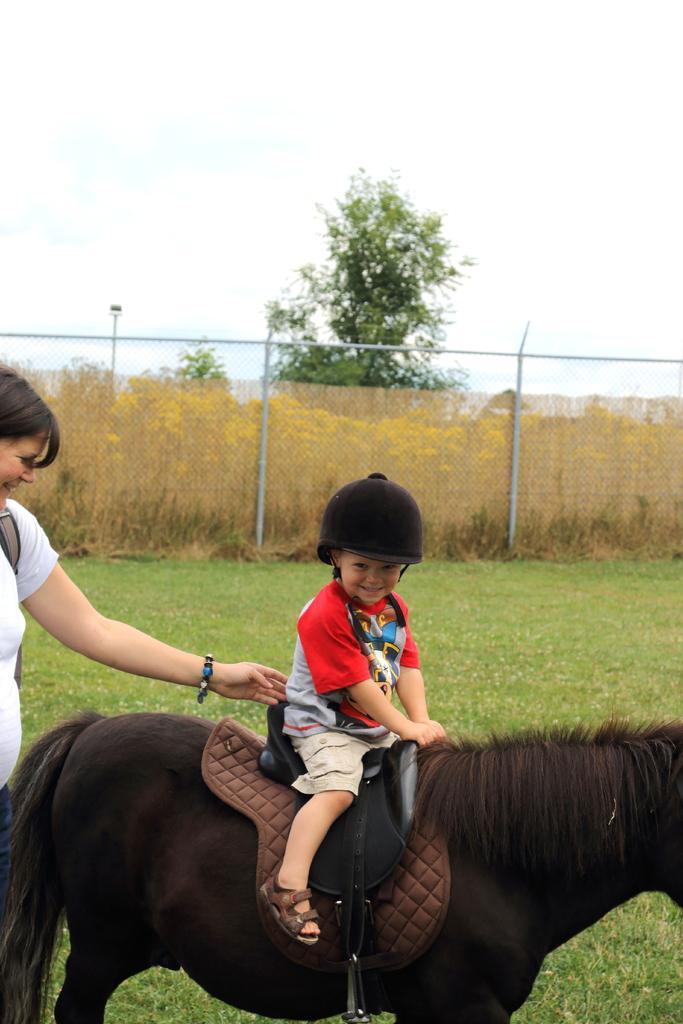In one or two sentences, can you explain what this image depicts? In the picture, there is a black color horse,on the horse a kid is sitting, beside him a woman is standing and pampering him,in the background there is a grass, a fence,outside the fence there is a tree and sky. 